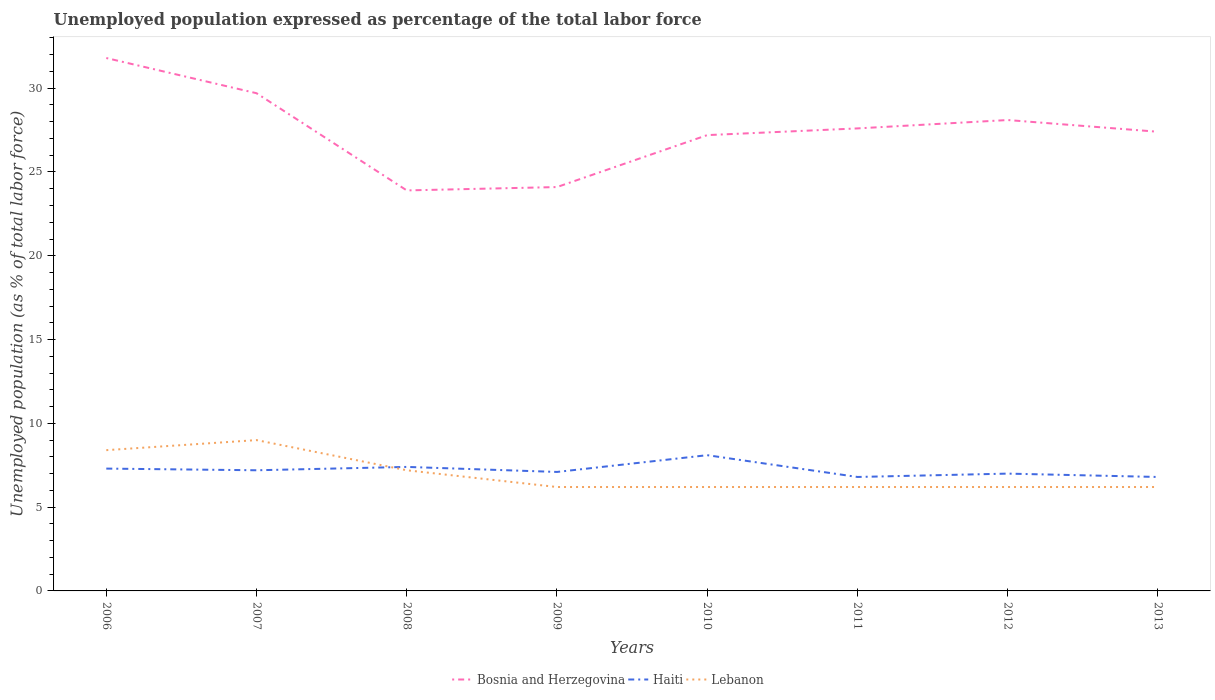How many different coloured lines are there?
Give a very brief answer. 3. Does the line corresponding to Haiti intersect with the line corresponding to Lebanon?
Provide a short and direct response. Yes. Is the number of lines equal to the number of legend labels?
Offer a very short reply. Yes. Across all years, what is the maximum unemployment in in Bosnia and Herzegovina?
Provide a succinct answer. 23.9. In which year was the unemployment in in Bosnia and Herzegovina maximum?
Offer a terse response. 2008. What is the total unemployment in in Bosnia and Herzegovina in the graph?
Your answer should be very brief. -3.5. What is the difference between the highest and the second highest unemployment in in Lebanon?
Make the answer very short. 2.8. What is the difference between the highest and the lowest unemployment in in Lebanon?
Ensure brevity in your answer.  3. How many lines are there?
Offer a terse response. 3. What is the difference between two consecutive major ticks on the Y-axis?
Provide a succinct answer. 5. Are the values on the major ticks of Y-axis written in scientific E-notation?
Your answer should be compact. No. Does the graph contain grids?
Your response must be concise. No. How are the legend labels stacked?
Offer a very short reply. Horizontal. What is the title of the graph?
Keep it short and to the point. Unemployed population expressed as percentage of the total labor force. Does "Panama" appear as one of the legend labels in the graph?
Provide a succinct answer. No. What is the label or title of the Y-axis?
Keep it short and to the point. Unemployed population (as % of total labor force). What is the Unemployed population (as % of total labor force) in Bosnia and Herzegovina in 2006?
Your answer should be very brief. 31.8. What is the Unemployed population (as % of total labor force) of Haiti in 2006?
Offer a terse response. 7.3. What is the Unemployed population (as % of total labor force) of Lebanon in 2006?
Your answer should be very brief. 8.4. What is the Unemployed population (as % of total labor force) of Bosnia and Herzegovina in 2007?
Keep it short and to the point. 29.7. What is the Unemployed population (as % of total labor force) of Haiti in 2007?
Keep it short and to the point. 7.2. What is the Unemployed population (as % of total labor force) of Bosnia and Herzegovina in 2008?
Provide a short and direct response. 23.9. What is the Unemployed population (as % of total labor force) in Haiti in 2008?
Give a very brief answer. 7.4. What is the Unemployed population (as % of total labor force) in Lebanon in 2008?
Give a very brief answer. 7.2. What is the Unemployed population (as % of total labor force) in Bosnia and Herzegovina in 2009?
Your response must be concise. 24.1. What is the Unemployed population (as % of total labor force) in Haiti in 2009?
Keep it short and to the point. 7.1. What is the Unemployed population (as % of total labor force) of Lebanon in 2009?
Make the answer very short. 6.2. What is the Unemployed population (as % of total labor force) in Bosnia and Herzegovina in 2010?
Provide a succinct answer. 27.2. What is the Unemployed population (as % of total labor force) of Haiti in 2010?
Offer a terse response. 8.1. What is the Unemployed population (as % of total labor force) of Lebanon in 2010?
Your answer should be very brief. 6.2. What is the Unemployed population (as % of total labor force) of Bosnia and Herzegovina in 2011?
Your response must be concise. 27.6. What is the Unemployed population (as % of total labor force) of Haiti in 2011?
Make the answer very short. 6.8. What is the Unemployed population (as % of total labor force) in Lebanon in 2011?
Offer a very short reply. 6.2. What is the Unemployed population (as % of total labor force) of Bosnia and Herzegovina in 2012?
Your response must be concise. 28.1. What is the Unemployed population (as % of total labor force) of Haiti in 2012?
Make the answer very short. 7. What is the Unemployed population (as % of total labor force) in Lebanon in 2012?
Give a very brief answer. 6.2. What is the Unemployed population (as % of total labor force) in Bosnia and Herzegovina in 2013?
Ensure brevity in your answer.  27.4. What is the Unemployed population (as % of total labor force) in Haiti in 2013?
Offer a terse response. 6.8. What is the Unemployed population (as % of total labor force) of Lebanon in 2013?
Keep it short and to the point. 6.2. Across all years, what is the maximum Unemployed population (as % of total labor force) of Bosnia and Herzegovina?
Ensure brevity in your answer.  31.8. Across all years, what is the maximum Unemployed population (as % of total labor force) in Haiti?
Give a very brief answer. 8.1. Across all years, what is the maximum Unemployed population (as % of total labor force) of Lebanon?
Provide a succinct answer. 9. Across all years, what is the minimum Unemployed population (as % of total labor force) in Bosnia and Herzegovina?
Make the answer very short. 23.9. Across all years, what is the minimum Unemployed population (as % of total labor force) in Haiti?
Offer a very short reply. 6.8. Across all years, what is the minimum Unemployed population (as % of total labor force) of Lebanon?
Give a very brief answer. 6.2. What is the total Unemployed population (as % of total labor force) in Bosnia and Herzegovina in the graph?
Your answer should be very brief. 219.8. What is the total Unemployed population (as % of total labor force) in Haiti in the graph?
Your response must be concise. 57.7. What is the total Unemployed population (as % of total labor force) in Lebanon in the graph?
Your answer should be compact. 55.6. What is the difference between the Unemployed population (as % of total labor force) of Bosnia and Herzegovina in 2006 and that in 2009?
Provide a succinct answer. 7.7. What is the difference between the Unemployed population (as % of total labor force) in Haiti in 2006 and that in 2009?
Offer a terse response. 0.2. What is the difference between the Unemployed population (as % of total labor force) in Haiti in 2006 and that in 2010?
Your response must be concise. -0.8. What is the difference between the Unemployed population (as % of total labor force) in Lebanon in 2006 and that in 2010?
Give a very brief answer. 2.2. What is the difference between the Unemployed population (as % of total labor force) in Haiti in 2006 and that in 2011?
Offer a very short reply. 0.5. What is the difference between the Unemployed population (as % of total labor force) of Haiti in 2006 and that in 2012?
Provide a succinct answer. 0.3. What is the difference between the Unemployed population (as % of total labor force) in Lebanon in 2006 and that in 2012?
Provide a short and direct response. 2.2. What is the difference between the Unemployed population (as % of total labor force) of Haiti in 2006 and that in 2013?
Your response must be concise. 0.5. What is the difference between the Unemployed population (as % of total labor force) in Haiti in 2007 and that in 2008?
Your answer should be compact. -0.2. What is the difference between the Unemployed population (as % of total labor force) of Lebanon in 2007 and that in 2009?
Your answer should be compact. 2.8. What is the difference between the Unemployed population (as % of total labor force) in Bosnia and Herzegovina in 2007 and that in 2010?
Offer a terse response. 2.5. What is the difference between the Unemployed population (as % of total labor force) of Lebanon in 2007 and that in 2010?
Your answer should be compact. 2.8. What is the difference between the Unemployed population (as % of total labor force) in Haiti in 2007 and that in 2011?
Your answer should be compact. 0.4. What is the difference between the Unemployed population (as % of total labor force) of Haiti in 2007 and that in 2012?
Ensure brevity in your answer.  0.2. What is the difference between the Unemployed population (as % of total labor force) of Lebanon in 2007 and that in 2012?
Your answer should be very brief. 2.8. What is the difference between the Unemployed population (as % of total labor force) in Bosnia and Herzegovina in 2007 and that in 2013?
Your answer should be compact. 2.3. What is the difference between the Unemployed population (as % of total labor force) in Lebanon in 2007 and that in 2013?
Provide a short and direct response. 2.8. What is the difference between the Unemployed population (as % of total labor force) in Bosnia and Herzegovina in 2008 and that in 2009?
Offer a very short reply. -0.2. What is the difference between the Unemployed population (as % of total labor force) of Lebanon in 2008 and that in 2009?
Ensure brevity in your answer.  1. What is the difference between the Unemployed population (as % of total labor force) in Bosnia and Herzegovina in 2008 and that in 2010?
Provide a short and direct response. -3.3. What is the difference between the Unemployed population (as % of total labor force) in Haiti in 2008 and that in 2010?
Your response must be concise. -0.7. What is the difference between the Unemployed population (as % of total labor force) in Bosnia and Herzegovina in 2008 and that in 2011?
Offer a very short reply. -3.7. What is the difference between the Unemployed population (as % of total labor force) of Bosnia and Herzegovina in 2008 and that in 2012?
Ensure brevity in your answer.  -4.2. What is the difference between the Unemployed population (as % of total labor force) in Haiti in 2008 and that in 2012?
Your answer should be compact. 0.4. What is the difference between the Unemployed population (as % of total labor force) of Lebanon in 2008 and that in 2012?
Your response must be concise. 1. What is the difference between the Unemployed population (as % of total labor force) in Bosnia and Herzegovina in 2008 and that in 2013?
Provide a succinct answer. -3.5. What is the difference between the Unemployed population (as % of total labor force) in Haiti in 2009 and that in 2010?
Make the answer very short. -1. What is the difference between the Unemployed population (as % of total labor force) of Bosnia and Herzegovina in 2009 and that in 2012?
Your answer should be compact. -4. What is the difference between the Unemployed population (as % of total labor force) in Haiti in 2009 and that in 2012?
Make the answer very short. 0.1. What is the difference between the Unemployed population (as % of total labor force) in Lebanon in 2009 and that in 2012?
Your response must be concise. 0. What is the difference between the Unemployed population (as % of total labor force) in Haiti in 2010 and that in 2011?
Make the answer very short. 1.3. What is the difference between the Unemployed population (as % of total labor force) in Lebanon in 2010 and that in 2011?
Give a very brief answer. 0. What is the difference between the Unemployed population (as % of total labor force) in Haiti in 2010 and that in 2013?
Ensure brevity in your answer.  1.3. What is the difference between the Unemployed population (as % of total labor force) in Lebanon in 2010 and that in 2013?
Provide a succinct answer. 0. What is the difference between the Unemployed population (as % of total labor force) in Bosnia and Herzegovina in 2011 and that in 2012?
Make the answer very short. -0.5. What is the difference between the Unemployed population (as % of total labor force) of Haiti in 2011 and that in 2012?
Your answer should be compact. -0.2. What is the difference between the Unemployed population (as % of total labor force) of Lebanon in 2011 and that in 2012?
Keep it short and to the point. 0. What is the difference between the Unemployed population (as % of total labor force) in Haiti in 2011 and that in 2013?
Provide a succinct answer. 0. What is the difference between the Unemployed population (as % of total labor force) in Bosnia and Herzegovina in 2012 and that in 2013?
Ensure brevity in your answer.  0.7. What is the difference between the Unemployed population (as % of total labor force) in Haiti in 2012 and that in 2013?
Provide a succinct answer. 0.2. What is the difference between the Unemployed population (as % of total labor force) of Lebanon in 2012 and that in 2013?
Ensure brevity in your answer.  0. What is the difference between the Unemployed population (as % of total labor force) in Bosnia and Herzegovina in 2006 and the Unemployed population (as % of total labor force) in Haiti in 2007?
Offer a very short reply. 24.6. What is the difference between the Unemployed population (as % of total labor force) in Bosnia and Herzegovina in 2006 and the Unemployed population (as % of total labor force) in Lebanon in 2007?
Your response must be concise. 22.8. What is the difference between the Unemployed population (as % of total labor force) in Bosnia and Herzegovina in 2006 and the Unemployed population (as % of total labor force) in Haiti in 2008?
Your answer should be compact. 24.4. What is the difference between the Unemployed population (as % of total labor force) of Bosnia and Herzegovina in 2006 and the Unemployed population (as % of total labor force) of Lebanon in 2008?
Offer a terse response. 24.6. What is the difference between the Unemployed population (as % of total labor force) in Bosnia and Herzegovina in 2006 and the Unemployed population (as % of total labor force) in Haiti in 2009?
Make the answer very short. 24.7. What is the difference between the Unemployed population (as % of total labor force) of Bosnia and Herzegovina in 2006 and the Unemployed population (as % of total labor force) of Lebanon in 2009?
Provide a short and direct response. 25.6. What is the difference between the Unemployed population (as % of total labor force) in Bosnia and Herzegovina in 2006 and the Unemployed population (as % of total labor force) in Haiti in 2010?
Provide a succinct answer. 23.7. What is the difference between the Unemployed population (as % of total labor force) in Bosnia and Herzegovina in 2006 and the Unemployed population (as % of total labor force) in Lebanon in 2010?
Offer a very short reply. 25.6. What is the difference between the Unemployed population (as % of total labor force) in Bosnia and Herzegovina in 2006 and the Unemployed population (as % of total labor force) in Haiti in 2011?
Give a very brief answer. 25. What is the difference between the Unemployed population (as % of total labor force) in Bosnia and Herzegovina in 2006 and the Unemployed population (as % of total labor force) in Lebanon in 2011?
Keep it short and to the point. 25.6. What is the difference between the Unemployed population (as % of total labor force) in Haiti in 2006 and the Unemployed population (as % of total labor force) in Lebanon in 2011?
Provide a short and direct response. 1.1. What is the difference between the Unemployed population (as % of total labor force) in Bosnia and Herzegovina in 2006 and the Unemployed population (as % of total labor force) in Haiti in 2012?
Give a very brief answer. 24.8. What is the difference between the Unemployed population (as % of total labor force) of Bosnia and Herzegovina in 2006 and the Unemployed population (as % of total labor force) of Lebanon in 2012?
Provide a succinct answer. 25.6. What is the difference between the Unemployed population (as % of total labor force) in Bosnia and Herzegovina in 2006 and the Unemployed population (as % of total labor force) in Lebanon in 2013?
Give a very brief answer. 25.6. What is the difference between the Unemployed population (as % of total labor force) of Bosnia and Herzegovina in 2007 and the Unemployed population (as % of total labor force) of Haiti in 2008?
Provide a succinct answer. 22.3. What is the difference between the Unemployed population (as % of total labor force) of Bosnia and Herzegovina in 2007 and the Unemployed population (as % of total labor force) of Lebanon in 2008?
Provide a succinct answer. 22.5. What is the difference between the Unemployed population (as % of total labor force) in Bosnia and Herzegovina in 2007 and the Unemployed population (as % of total labor force) in Haiti in 2009?
Make the answer very short. 22.6. What is the difference between the Unemployed population (as % of total labor force) of Haiti in 2007 and the Unemployed population (as % of total labor force) of Lebanon in 2009?
Provide a succinct answer. 1. What is the difference between the Unemployed population (as % of total labor force) of Bosnia and Herzegovina in 2007 and the Unemployed population (as % of total labor force) of Haiti in 2010?
Make the answer very short. 21.6. What is the difference between the Unemployed population (as % of total labor force) in Bosnia and Herzegovina in 2007 and the Unemployed population (as % of total labor force) in Lebanon in 2010?
Your response must be concise. 23.5. What is the difference between the Unemployed population (as % of total labor force) of Bosnia and Herzegovina in 2007 and the Unemployed population (as % of total labor force) of Haiti in 2011?
Provide a short and direct response. 22.9. What is the difference between the Unemployed population (as % of total labor force) of Bosnia and Herzegovina in 2007 and the Unemployed population (as % of total labor force) of Lebanon in 2011?
Your response must be concise. 23.5. What is the difference between the Unemployed population (as % of total labor force) in Bosnia and Herzegovina in 2007 and the Unemployed population (as % of total labor force) in Haiti in 2012?
Your answer should be very brief. 22.7. What is the difference between the Unemployed population (as % of total labor force) in Bosnia and Herzegovina in 2007 and the Unemployed population (as % of total labor force) in Haiti in 2013?
Your answer should be compact. 22.9. What is the difference between the Unemployed population (as % of total labor force) of Haiti in 2007 and the Unemployed population (as % of total labor force) of Lebanon in 2013?
Offer a very short reply. 1. What is the difference between the Unemployed population (as % of total labor force) of Bosnia and Herzegovina in 2008 and the Unemployed population (as % of total labor force) of Lebanon in 2009?
Give a very brief answer. 17.7. What is the difference between the Unemployed population (as % of total labor force) in Bosnia and Herzegovina in 2008 and the Unemployed population (as % of total labor force) in Haiti in 2010?
Give a very brief answer. 15.8. What is the difference between the Unemployed population (as % of total labor force) in Bosnia and Herzegovina in 2008 and the Unemployed population (as % of total labor force) in Lebanon in 2010?
Your answer should be very brief. 17.7. What is the difference between the Unemployed population (as % of total labor force) of Bosnia and Herzegovina in 2008 and the Unemployed population (as % of total labor force) of Haiti in 2011?
Give a very brief answer. 17.1. What is the difference between the Unemployed population (as % of total labor force) in Bosnia and Herzegovina in 2008 and the Unemployed population (as % of total labor force) in Lebanon in 2011?
Offer a terse response. 17.7. What is the difference between the Unemployed population (as % of total labor force) in Haiti in 2008 and the Unemployed population (as % of total labor force) in Lebanon in 2011?
Make the answer very short. 1.2. What is the difference between the Unemployed population (as % of total labor force) of Haiti in 2008 and the Unemployed population (as % of total labor force) of Lebanon in 2012?
Keep it short and to the point. 1.2. What is the difference between the Unemployed population (as % of total labor force) of Bosnia and Herzegovina in 2009 and the Unemployed population (as % of total labor force) of Haiti in 2010?
Keep it short and to the point. 16. What is the difference between the Unemployed population (as % of total labor force) of Bosnia and Herzegovina in 2009 and the Unemployed population (as % of total labor force) of Lebanon in 2010?
Ensure brevity in your answer.  17.9. What is the difference between the Unemployed population (as % of total labor force) of Haiti in 2009 and the Unemployed population (as % of total labor force) of Lebanon in 2010?
Your answer should be compact. 0.9. What is the difference between the Unemployed population (as % of total labor force) of Bosnia and Herzegovina in 2009 and the Unemployed population (as % of total labor force) of Haiti in 2011?
Provide a succinct answer. 17.3. What is the difference between the Unemployed population (as % of total labor force) of Bosnia and Herzegovina in 2009 and the Unemployed population (as % of total labor force) of Lebanon in 2011?
Give a very brief answer. 17.9. What is the difference between the Unemployed population (as % of total labor force) in Bosnia and Herzegovina in 2009 and the Unemployed population (as % of total labor force) in Haiti in 2012?
Make the answer very short. 17.1. What is the difference between the Unemployed population (as % of total labor force) of Bosnia and Herzegovina in 2009 and the Unemployed population (as % of total labor force) of Lebanon in 2012?
Your answer should be very brief. 17.9. What is the difference between the Unemployed population (as % of total labor force) of Haiti in 2009 and the Unemployed population (as % of total labor force) of Lebanon in 2012?
Make the answer very short. 0.9. What is the difference between the Unemployed population (as % of total labor force) in Bosnia and Herzegovina in 2009 and the Unemployed population (as % of total labor force) in Haiti in 2013?
Make the answer very short. 17.3. What is the difference between the Unemployed population (as % of total labor force) of Bosnia and Herzegovina in 2009 and the Unemployed population (as % of total labor force) of Lebanon in 2013?
Make the answer very short. 17.9. What is the difference between the Unemployed population (as % of total labor force) in Haiti in 2009 and the Unemployed population (as % of total labor force) in Lebanon in 2013?
Offer a very short reply. 0.9. What is the difference between the Unemployed population (as % of total labor force) in Bosnia and Herzegovina in 2010 and the Unemployed population (as % of total labor force) in Haiti in 2011?
Make the answer very short. 20.4. What is the difference between the Unemployed population (as % of total labor force) of Bosnia and Herzegovina in 2010 and the Unemployed population (as % of total labor force) of Lebanon in 2011?
Your response must be concise. 21. What is the difference between the Unemployed population (as % of total labor force) in Bosnia and Herzegovina in 2010 and the Unemployed population (as % of total labor force) in Haiti in 2012?
Keep it short and to the point. 20.2. What is the difference between the Unemployed population (as % of total labor force) in Haiti in 2010 and the Unemployed population (as % of total labor force) in Lebanon in 2012?
Your response must be concise. 1.9. What is the difference between the Unemployed population (as % of total labor force) in Bosnia and Herzegovina in 2010 and the Unemployed population (as % of total labor force) in Haiti in 2013?
Ensure brevity in your answer.  20.4. What is the difference between the Unemployed population (as % of total labor force) of Bosnia and Herzegovina in 2011 and the Unemployed population (as % of total labor force) of Haiti in 2012?
Provide a short and direct response. 20.6. What is the difference between the Unemployed population (as % of total labor force) in Bosnia and Herzegovina in 2011 and the Unemployed population (as % of total labor force) in Lebanon in 2012?
Provide a succinct answer. 21.4. What is the difference between the Unemployed population (as % of total labor force) in Bosnia and Herzegovina in 2011 and the Unemployed population (as % of total labor force) in Haiti in 2013?
Ensure brevity in your answer.  20.8. What is the difference between the Unemployed population (as % of total labor force) of Bosnia and Herzegovina in 2011 and the Unemployed population (as % of total labor force) of Lebanon in 2013?
Offer a very short reply. 21.4. What is the difference between the Unemployed population (as % of total labor force) of Bosnia and Herzegovina in 2012 and the Unemployed population (as % of total labor force) of Haiti in 2013?
Provide a succinct answer. 21.3. What is the difference between the Unemployed population (as % of total labor force) in Bosnia and Herzegovina in 2012 and the Unemployed population (as % of total labor force) in Lebanon in 2013?
Your answer should be compact. 21.9. What is the average Unemployed population (as % of total labor force) in Bosnia and Herzegovina per year?
Ensure brevity in your answer.  27.48. What is the average Unemployed population (as % of total labor force) in Haiti per year?
Give a very brief answer. 7.21. What is the average Unemployed population (as % of total labor force) in Lebanon per year?
Your answer should be compact. 6.95. In the year 2006, what is the difference between the Unemployed population (as % of total labor force) in Bosnia and Herzegovina and Unemployed population (as % of total labor force) in Haiti?
Give a very brief answer. 24.5. In the year 2006, what is the difference between the Unemployed population (as % of total labor force) in Bosnia and Herzegovina and Unemployed population (as % of total labor force) in Lebanon?
Offer a very short reply. 23.4. In the year 2007, what is the difference between the Unemployed population (as % of total labor force) in Bosnia and Herzegovina and Unemployed population (as % of total labor force) in Haiti?
Offer a very short reply. 22.5. In the year 2007, what is the difference between the Unemployed population (as % of total labor force) of Bosnia and Herzegovina and Unemployed population (as % of total labor force) of Lebanon?
Ensure brevity in your answer.  20.7. In the year 2007, what is the difference between the Unemployed population (as % of total labor force) of Haiti and Unemployed population (as % of total labor force) of Lebanon?
Offer a very short reply. -1.8. In the year 2008, what is the difference between the Unemployed population (as % of total labor force) in Bosnia and Herzegovina and Unemployed population (as % of total labor force) in Haiti?
Your response must be concise. 16.5. In the year 2008, what is the difference between the Unemployed population (as % of total labor force) in Bosnia and Herzegovina and Unemployed population (as % of total labor force) in Lebanon?
Your response must be concise. 16.7. In the year 2009, what is the difference between the Unemployed population (as % of total labor force) of Bosnia and Herzegovina and Unemployed population (as % of total labor force) of Lebanon?
Provide a short and direct response. 17.9. In the year 2009, what is the difference between the Unemployed population (as % of total labor force) of Haiti and Unemployed population (as % of total labor force) of Lebanon?
Ensure brevity in your answer.  0.9. In the year 2010, what is the difference between the Unemployed population (as % of total labor force) of Bosnia and Herzegovina and Unemployed population (as % of total labor force) of Haiti?
Ensure brevity in your answer.  19.1. In the year 2010, what is the difference between the Unemployed population (as % of total labor force) in Bosnia and Herzegovina and Unemployed population (as % of total labor force) in Lebanon?
Offer a terse response. 21. In the year 2011, what is the difference between the Unemployed population (as % of total labor force) in Bosnia and Herzegovina and Unemployed population (as % of total labor force) in Haiti?
Ensure brevity in your answer.  20.8. In the year 2011, what is the difference between the Unemployed population (as % of total labor force) of Bosnia and Herzegovina and Unemployed population (as % of total labor force) of Lebanon?
Your answer should be compact. 21.4. In the year 2012, what is the difference between the Unemployed population (as % of total labor force) of Bosnia and Herzegovina and Unemployed population (as % of total labor force) of Haiti?
Provide a succinct answer. 21.1. In the year 2012, what is the difference between the Unemployed population (as % of total labor force) in Bosnia and Herzegovina and Unemployed population (as % of total labor force) in Lebanon?
Ensure brevity in your answer.  21.9. In the year 2012, what is the difference between the Unemployed population (as % of total labor force) of Haiti and Unemployed population (as % of total labor force) of Lebanon?
Your answer should be very brief. 0.8. In the year 2013, what is the difference between the Unemployed population (as % of total labor force) in Bosnia and Herzegovina and Unemployed population (as % of total labor force) in Haiti?
Your answer should be compact. 20.6. In the year 2013, what is the difference between the Unemployed population (as % of total labor force) in Bosnia and Herzegovina and Unemployed population (as % of total labor force) in Lebanon?
Keep it short and to the point. 21.2. In the year 2013, what is the difference between the Unemployed population (as % of total labor force) in Haiti and Unemployed population (as % of total labor force) in Lebanon?
Ensure brevity in your answer.  0.6. What is the ratio of the Unemployed population (as % of total labor force) of Bosnia and Herzegovina in 2006 to that in 2007?
Give a very brief answer. 1.07. What is the ratio of the Unemployed population (as % of total labor force) in Haiti in 2006 to that in 2007?
Your answer should be compact. 1.01. What is the ratio of the Unemployed population (as % of total labor force) in Lebanon in 2006 to that in 2007?
Keep it short and to the point. 0.93. What is the ratio of the Unemployed population (as % of total labor force) of Bosnia and Herzegovina in 2006 to that in 2008?
Offer a terse response. 1.33. What is the ratio of the Unemployed population (as % of total labor force) in Haiti in 2006 to that in 2008?
Offer a terse response. 0.99. What is the ratio of the Unemployed population (as % of total labor force) in Bosnia and Herzegovina in 2006 to that in 2009?
Ensure brevity in your answer.  1.32. What is the ratio of the Unemployed population (as % of total labor force) in Haiti in 2006 to that in 2009?
Offer a terse response. 1.03. What is the ratio of the Unemployed population (as % of total labor force) in Lebanon in 2006 to that in 2009?
Ensure brevity in your answer.  1.35. What is the ratio of the Unemployed population (as % of total labor force) of Bosnia and Herzegovina in 2006 to that in 2010?
Your answer should be very brief. 1.17. What is the ratio of the Unemployed population (as % of total labor force) of Haiti in 2006 to that in 2010?
Ensure brevity in your answer.  0.9. What is the ratio of the Unemployed population (as % of total labor force) of Lebanon in 2006 to that in 2010?
Offer a very short reply. 1.35. What is the ratio of the Unemployed population (as % of total labor force) of Bosnia and Herzegovina in 2006 to that in 2011?
Give a very brief answer. 1.15. What is the ratio of the Unemployed population (as % of total labor force) of Haiti in 2006 to that in 2011?
Your response must be concise. 1.07. What is the ratio of the Unemployed population (as % of total labor force) of Lebanon in 2006 to that in 2011?
Give a very brief answer. 1.35. What is the ratio of the Unemployed population (as % of total labor force) in Bosnia and Herzegovina in 2006 to that in 2012?
Provide a succinct answer. 1.13. What is the ratio of the Unemployed population (as % of total labor force) of Haiti in 2006 to that in 2012?
Provide a short and direct response. 1.04. What is the ratio of the Unemployed population (as % of total labor force) in Lebanon in 2006 to that in 2012?
Your answer should be compact. 1.35. What is the ratio of the Unemployed population (as % of total labor force) of Bosnia and Herzegovina in 2006 to that in 2013?
Offer a terse response. 1.16. What is the ratio of the Unemployed population (as % of total labor force) in Haiti in 2006 to that in 2013?
Provide a succinct answer. 1.07. What is the ratio of the Unemployed population (as % of total labor force) in Lebanon in 2006 to that in 2013?
Make the answer very short. 1.35. What is the ratio of the Unemployed population (as % of total labor force) of Bosnia and Herzegovina in 2007 to that in 2008?
Provide a short and direct response. 1.24. What is the ratio of the Unemployed population (as % of total labor force) of Haiti in 2007 to that in 2008?
Provide a short and direct response. 0.97. What is the ratio of the Unemployed population (as % of total labor force) of Lebanon in 2007 to that in 2008?
Your answer should be very brief. 1.25. What is the ratio of the Unemployed population (as % of total labor force) of Bosnia and Herzegovina in 2007 to that in 2009?
Provide a short and direct response. 1.23. What is the ratio of the Unemployed population (as % of total labor force) of Haiti in 2007 to that in 2009?
Ensure brevity in your answer.  1.01. What is the ratio of the Unemployed population (as % of total labor force) in Lebanon in 2007 to that in 2009?
Your response must be concise. 1.45. What is the ratio of the Unemployed population (as % of total labor force) in Bosnia and Herzegovina in 2007 to that in 2010?
Provide a succinct answer. 1.09. What is the ratio of the Unemployed population (as % of total labor force) of Haiti in 2007 to that in 2010?
Provide a short and direct response. 0.89. What is the ratio of the Unemployed population (as % of total labor force) in Lebanon in 2007 to that in 2010?
Give a very brief answer. 1.45. What is the ratio of the Unemployed population (as % of total labor force) in Bosnia and Herzegovina in 2007 to that in 2011?
Your answer should be compact. 1.08. What is the ratio of the Unemployed population (as % of total labor force) of Haiti in 2007 to that in 2011?
Offer a very short reply. 1.06. What is the ratio of the Unemployed population (as % of total labor force) in Lebanon in 2007 to that in 2011?
Provide a succinct answer. 1.45. What is the ratio of the Unemployed population (as % of total labor force) of Bosnia and Herzegovina in 2007 to that in 2012?
Keep it short and to the point. 1.06. What is the ratio of the Unemployed population (as % of total labor force) of Haiti in 2007 to that in 2012?
Your answer should be compact. 1.03. What is the ratio of the Unemployed population (as % of total labor force) in Lebanon in 2007 to that in 2012?
Your answer should be compact. 1.45. What is the ratio of the Unemployed population (as % of total labor force) of Bosnia and Herzegovina in 2007 to that in 2013?
Offer a terse response. 1.08. What is the ratio of the Unemployed population (as % of total labor force) in Haiti in 2007 to that in 2013?
Offer a very short reply. 1.06. What is the ratio of the Unemployed population (as % of total labor force) in Lebanon in 2007 to that in 2013?
Keep it short and to the point. 1.45. What is the ratio of the Unemployed population (as % of total labor force) in Bosnia and Herzegovina in 2008 to that in 2009?
Provide a short and direct response. 0.99. What is the ratio of the Unemployed population (as % of total labor force) of Haiti in 2008 to that in 2009?
Your answer should be compact. 1.04. What is the ratio of the Unemployed population (as % of total labor force) of Lebanon in 2008 to that in 2009?
Provide a short and direct response. 1.16. What is the ratio of the Unemployed population (as % of total labor force) of Bosnia and Herzegovina in 2008 to that in 2010?
Make the answer very short. 0.88. What is the ratio of the Unemployed population (as % of total labor force) in Haiti in 2008 to that in 2010?
Your answer should be very brief. 0.91. What is the ratio of the Unemployed population (as % of total labor force) of Lebanon in 2008 to that in 2010?
Ensure brevity in your answer.  1.16. What is the ratio of the Unemployed population (as % of total labor force) in Bosnia and Herzegovina in 2008 to that in 2011?
Provide a succinct answer. 0.87. What is the ratio of the Unemployed population (as % of total labor force) in Haiti in 2008 to that in 2011?
Keep it short and to the point. 1.09. What is the ratio of the Unemployed population (as % of total labor force) of Lebanon in 2008 to that in 2011?
Provide a short and direct response. 1.16. What is the ratio of the Unemployed population (as % of total labor force) in Bosnia and Herzegovina in 2008 to that in 2012?
Keep it short and to the point. 0.85. What is the ratio of the Unemployed population (as % of total labor force) in Haiti in 2008 to that in 2012?
Provide a short and direct response. 1.06. What is the ratio of the Unemployed population (as % of total labor force) of Lebanon in 2008 to that in 2012?
Give a very brief answer. 1.16. What is the ratio of the Unemployed population (as % of total labor force) in Bosnia and Herzegovina in 2008 to that in 2013?
Your response must be concise. 0.87. What is the ratio of the Unemployed population (as % of total labor force) of Haiti in 2008 to that in 2013?
Offer a very short reply. 1.09. What is the ratio of the Unemployed population (as % of total labor force) of Lebanon in 2008 to that in 2013?
Your answer should be compact. 1.16. What is the ratio of the Unemployed population (as % of total labor force) of Bosnia and Herzegovina in 2009 to that in 2010?
Your answer should be compact. 0.89. What is the ratio of the Unemployed population (as % of total labor force) in Haiti in 2009 to that in 2010?
Keep it short and to the point. 0.88. What is the ratio of the Unemployed population (as % of total labor force) in Lebanon in 2009 to that in 2010?
Keep it short and to the point. 1. What is the ratio of the Unemployed population (as % of total labor force) of Bosnia and Herzegovina in 2009 to that in 2011?
Your answer should be very brief. 0.87. What is the ratio of the Unemployed population (as % of total labor force) in Haiti in 2009 to that in 2011?
Your answer should be compact. 1.04. What is the ratio of the Unemployed population (as % of total labor force) of Lebanon in 2009 to that in 2011?
Your answer should be very brief. 1. What is the ratio of the Unemployed population (as % of total labor force) in Bosnia and Herzegovina in 2009 to that in 2012?
Provide a succinct answer. 0.86. What is the ratio of the Unemployed population (as % of total labor force) of Haiti in 2009 to that in 2012?
Give a very brief answer. 1.01. What is the ratio of the Unemployed population (as % of total labor force) in Lebanon in 2009 to that in 2012?
Provide a succinct answer. 1. What is the ratio of the Unemployed population (as % of total labor force) in Bosnia and Herzegovina in 2009 to that in 2013?
Your answer should be compact. 0.88. What is the ratio of the Unemployed population (as % of total labor force) of Haiti in 2009 to that in 2013?
Provide a succinct answer. 1.04. What is the ratio of the Unemployed population (as % of total labor force) of Bosnia and Herzegovina in 2010 to that in 2011?
Keep it short and to the point. 0.99. What is the ratio of the Unemployed population (as % of total labor force) in Haiti in 2010 to that in 2011?
Ensure brevity in your answer.  1.19. What is the ratio of the Unemployed population (as % of total labor force) of Lebanon in 2010 to that in 2011?
Ensure brevity in your answer.  1. What is the ratio of the Unemployed population (as % of total labor force) in Haiti in 2010 to that in 2012?
Your answer should be compact. 1.16. What is the ratio of the Unemployed population (as % of total labor force) of Lebanon in 2010 to that in 2012?
Provide a succinct answer. 1. What is the ratio of the Unemployed population (as % of total labor force) of Haiti in 2010 to that in 2013?
Offer a very short reply. 1.19. What is the ratio of the Unemployed population (as % of total labor force) of Bosnia and Herzegovina in 2011 to that in 2012?
Give a very brief answer. 0.98. What is the ratio of the Unemployed population (as % of total labor force) of Haiti in 2011 to that in 2012?
Keep it short and to the point. 0.97. What is the ratio of the Unemployed population (as % of total labor force) in Lebanon in 2011 to that in 2012?
Your answer should be very brief. 1. What is the ratio of the Unemployed population (as % of total labor force) of Bosnia and Herzegovina in 2011 to that in 2013?
Keep it short and to the point. 1.01. What is the ratio of the Unemployed population (as % of total labor force) of Haiti in 2011 to that in 2013?
Your answer should be very brief. 1. What is the ratio of the Unemployed population (as % of total labor force) of Lebanon in 2011 to that in 2013?
Keep it short and to the point. 1. What is the ratio of the Unemployed population (as % of total labor force) of Bosnia and Herzegovina in 2012 to that in 2013?
Offer a terse response. 1.03. What is the ratio of the Unemployed population (as % of total labor force) of Haiti in 2012 to that in 2013?
Your answer should be compact. 1.03. What is the ratio of the Unemployed population (as % of total labor force) in Lebanon in 2012 to that in 2013?
Make the answer very short. 1. What is the difference between the highest and the second highest Unemployed population (as % of total labor force) in Lebanon?
Offer a very short reply. 0.6. What is the difference between the highest and the lowest Unemployed population (as % of total labor force) in Haiti?
Offer a terse response. 1.3. What is the difference between the highest and the lowest Unemployed population (as % of total labor force) of Lebanon?
Offer a terse response. 2.8. 